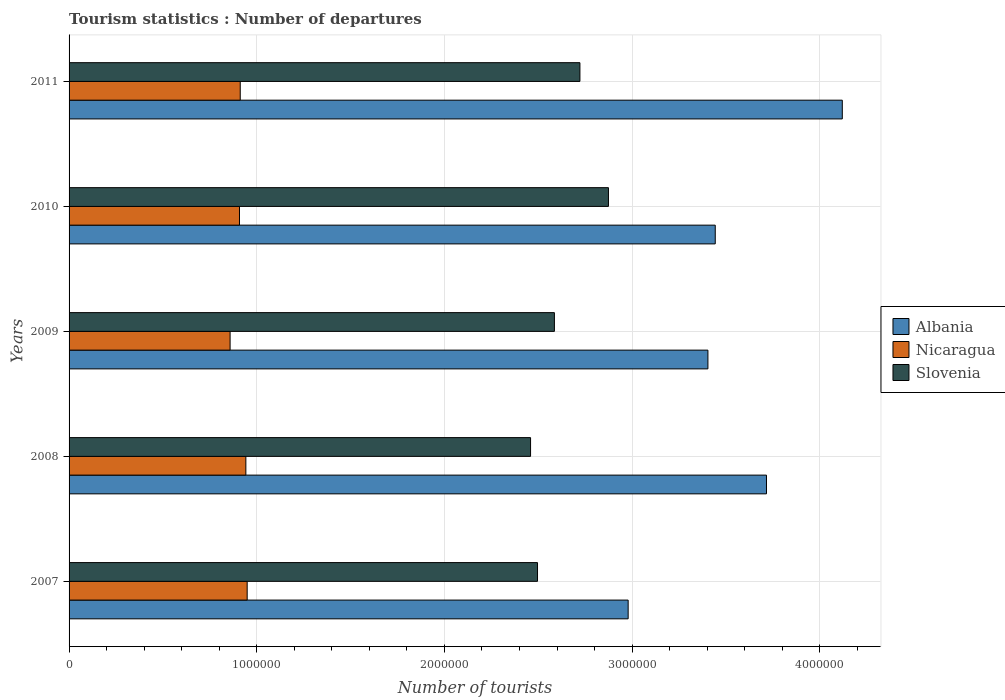Are the number of bars on each tick of the Y-axis equal?
Make the answer very short. Yes. How many bars are there on the 4th tick from the top?
Offer a terse response. 3. How many bars are there on the 3rd tick from the bottom?
Keep it short and to the point. 3. What is the label of the 5th group of bars from the top?
Your answer should be compact. 2007. In how many cases, is the number of bars for a given year not equal to the number of legend labels?
Ensure brevity in your answer.  0. What is the number of tourist departures in Slovenia in 2010?
Give a very brief answer. 2.87e+06. Across all years, what is the maximum number of tourist departures in Nicaragua?
Offer a terse response. 9.49e+05. Across all years, what is the minimum number of tourist departures in Nicaragua?
Offer a very short reply. 8.58e+05. What is the total number of tourist departures in Albania in the graph?
Your answer should be very brief. 1.77e+07. What is the difference between the number of tourist departures in Nicaragua in 2008 and that in 2011?
Provide a succinct answer. 3.00e+04. What is the difference between the number of tourist departures in Slovenia in 2009 and the number of tourist departures in Albania in 2008?
Ensure brevity in your answer.  -1.13e+06. What is the average number of tourist departures in Nicaragua per year?
Your answer should be compact. 9.14e+05. In the year 2009, what is the difference between the number of tourist departures in Slovenia and number of tourist departures in Albania?
Your answer should be very brief. -8.18e+05. What is the ratio of the number of tourist departures in Nicaragua in 2007 to that in 2010?
Offer a terse response. 1.05. What is the difference between the highest and the second highest number of tourist departures in Slovenia?
Make the answer very short. 1.52e+05. What is the difference between the highest and the lowest number of tourist departures in Albania?
Your answer should be very brief. 1.14e+06. In how many years, is the number of tourist departures in Albania greater than the average number of tourist departures in Albania taken over all years?
Make the answer very short. 2. Is the sum of the number of tourist departures in Albania in 2007 and 2009 greater than the maximum number of tourist departures in Nicaragua across all years?
Provide a short and direct response. Yes. What does the 1st bar from the top in 2008 represents?
Your answer should be compact. Slovenia. What does the 3rd bar from the bottom in 2009 represents?
Make the answer very short. Slovenia. Are all the bars in the graph horizontal?
Give a very brief answer. Yes. What is the difference between two consecutive major ticks on the X-axis?
Provide a short and direct response. 1.00e+06. Are the values on the major ticks of X-axis written in scientific E-notation?
Your answer should be compact. No. Does the graph contain any zero values?
Offer a terse response. No. How many legend labels are there?
Offer a very short reply. 3. What is the title of the graph?
Make the answer very short. Tourism statistics : Number of departures. Does "Botswana" appear as one of the legend labels in the graph?
Keep it short and to the point. No. What is the label or title of the X-axis?
Make the answer very short. Number of tourists. What is the label or title of the Y-axis?
Provide a succinct answer. Years. What is the Number of tourists of Albania in 2007?
Your answer should be compact. 2.98e+06. What is the Number of tourists in Nicaragua in 2007?
Your answer should be very brief. 9.49e+05. What is the Number of tourists of Slovenia in 2007?
Your response must be concise. 2.50e+06. What is the Number of tourists of Albania in 2008?
Offer a very short reply. 3.72e+06. What is the Number of tourists in Nicaragua in 2008?
Offer a terse response. 9.42e+05. What is the Number of tourists of Slovenia in 2008?
Your answer should be compact. 2.46e+06. What is the Number of tourists in Albania in 2009?
Ensure brevity in your answer.  3.40e+06. What is the Number of tourists of Nicaragua in 2009?
Provide a succinct answer. 8.58e+05. What is the Number of tourists of Slovenia in 2009?
Offer a very short reply. 2.59e+06. What is the Number of tourists in Albania in 2010?
Ensure brevity in your answer.  3.44e+06. What is the Number of tourists in Nicaragua in 2010?
Keep it short and to the point. 9.08e+05. What is the Number of tourists in Slovenia in 2010?
Your answer should be very brief. 2.87e+06. What is the Number of tourists in Albania in 2011?
Your answer should be very brief. 4.12e+06. What is the Number of tourists in Nicaragua in 2011?
Your answer should be very brief. 9.12e+05. What is the Number of tourists of Slovenia in 2011?
Your answer should be very brief. 2.72e+06. Across all years, what is the maximum Number of tourists of Albania?
Your answer should be compact. 4.12e+06. Across all years, what is the maximum Number of tourists of Nicaragua?
Offer a very short reply. 9.49e+05. Across all years, what is the maximum Number of tourists of Slovenia?
Provide a short and direct response. 2.87e+06. Across all years, what is the minimum Number of tourists in Albania?
Provide a short and direct response. 2.98e+06. Across all years, what is the minimum Number of tourists of Nicaragua?
Provide a succinct answer. 8.58e+05. Across all years, what is the minimum Number of tourists of Slovenia?
Your response must be concise. 2.46e+06. What is the total Number of tourists of Albania in the graph?
Give a very brief answer. 1.77e+07. What is the total Number of tourists in Nicaragua in the graph?
Offer a very short reply. 4.57e+06. What is the total Number of tourists of Slovenia in the graph?
Make the answer very short. 1.31e+07. What is the difference between the Number of tourists in Albania in 2007 and that in 2008?
Offer a terse response. -7.37e+05. What is the difference between the Number of tourists of Nicaragua in 2007 and that in 2008?
Offer a terse response. 7000. What is the difference between the Number of tourists of Slovenia in 2007 and that in 2008?
Ensure brevity in your answer.  3.70e+04. What is the difference between the Number of tourists in Albania in 2007 and that in 2009?
Give a very brief answer. -4.25e+05. What is the difference between the Number of tourists of Nicaragua in 2007 and that in 2009?
Offer a very short reply. 9.10e+04. What is the difference between the Number of tourists of Albania in 2007 and that in 2010?
Your answer should be compact. -4.64e+05. What is the difference between the Number of tourists of Nicaragua in 2007 and that in 2010?
Make the answer very short. 4.10e+04. What is the difference between the Number of tourists of Slovenia in 2007 and that in 2010?
Ensure brevity in your answer.  -3.78e+05. What is the difference between the Number of tourists of Albania in 2007 and that in 2011?
Offer a terse response. -1.14e+06. What is the difference between the Number of tourists of Nicaragua in 2007 and that in 2011?
Ensure brevity in your answer.  3.70e+04. What is the difference between the Number of tourists of Slovenia in 2007 and that in 2011?
Ensure brevity in your answer.  -2.26e+05. What is the difference between the Number of tourists of Albania in 2008 and that in 2009?
Give a very brief answer. 3.12e+05. What is the difference between the Number of tourists in Nicaragua in 2008 and that in 2009?
Provide a succinct answer. 8.40e+04. What is the difference between the Number of tourists of Slovenia in 2008 and that in 2009?
Your answer should be very brief. -1.27e+05. What is the difference between the Number of tourists in Albania in 2008 and that in 2010?
Provide a short and direct response. 2.73e+05. What is the difference between the Number of tourists of Nicaragua in 2008 and that in 2010?
Ensure brevity in your answer.  3.40e+04. What is the difference between the Number of tourists of Slovenia in 2008 and that in 2010?
Give a very brief answer. -4.15e+05. What is the difference between the Number of tourists of Albania in 2008 and that in 2011?
Your answer should be very brief. -4.04e+05. What is the difference between the Number of tourists of Slovenia in 2008 and that in 2011?
Ensure brevity in your answer.  -2.63e+05. What is the difference between the Number of tourists in Albania in 2009 and that in 2010?
Keep it short and to the point. -3.90e+04. What is the difference between the Number of tourists of Slovenia in 2009 and that in 2010?
Provide a short and direct response. -2.88e+05. What is the difference between the Number of tourists of Albania in 2009 and that in 2011?
Keep it short and to the point. -7.16e+05. What is the difference between the Number of tourists in Nicaragua in 2009 and that in 2011?
Offer a terse response. -5.40e+04. What is the difference between the Number of tourists of Slovenia in 2009 and that in 2011?
Provide a short and direct response. -1.36e+05. What is the difference between the Number of tourists of Albania in 2010 and that in 2011?
Give a very brief answer. -6.77e+05. What is the difference between the Number of tourists in Nicaragua in 2010 and that in 2011?
Give a very brief answer. -4000. What is the difference between the Number of tourists of Slovenia in 2010 and that in 2011?
Provide a short and direct response. 1.52e+05. What is the difference between the Number of tourists in Albania in 2007 and the Number of tourists in Nicaragua in 2008?
Your answer should be compact. 2.04e+06. What is the difference between the Number of tourists in Albania in 2007 and the Number of tourists in Slovenia in 2008?
Your answer should be compact. 5.20e+05. What is the difference between the Number of tourists of Nicaragua in 2007 and the Number of tourists of Slovenia in 2008?
Offer a terse response. -1.51e+06. What is the difference between the Number of tourists in Albania in 2007 and the Number of tourists in Nicaragua in 2009?
Your response must be concise. 2.12e+06. What is the difference between the Number of tourists of Albania in 2007 and the Number of tourists of Slovenia in 2009?
Provide a short and direct response. 3.93e+05. What is the difference between the Number of tourists in Nicaragua in 2007 and the Number of tourists in Slovenia in 2009?
Provide a short and direct response. -1.64e+06. What is the difference between the Number of tourists of Albania in 2007 and the Number of tourists of Nicaragua in 2010?
Your response must be concise. 2.07e+06. What is the difference between the Number of tourists in Albania in 2007 and the Number of tourists in Slovenia in 2010?
Make the answer very short. 1.05e+05. What is the difference between the Number of tourists in Nicaragua in 2007 and the Number of tourists in Slovenia in 2010?
Keep it short and to the point. -1.92e+06. What is the difference between the Number of tourists in Albania in 2007 and the Number of tourists in Nicaragua in 2011?
Keep it short and to the point. 2.07e+06. What is the difference between the Number of tourists of Albania in 2007 and the Number of tourists of Slovenia in 2011?
Your answer should be very brief. 2.57e+05. What is the difference between the Number of tourists of Nicaragua in 2007 and the Number of tourists of Slovenia in 2011?
Keep it short and to the point. -1.77e+06. What is the difference between the Number of tourists of Albania in 2008 and the Number of tourists of Nicaragua in 2009?
Give a very brief answer. 2.86e+06. What is the difference between the Number of tourists in Albania in 2008 and the Number of tourists in Slovenia in 2009?
Your answer should be compact. 1.13e+06. What is the difference between the Number of tourists in Nicaragua in 2008 and the Number of tourists in Slovenia in 2009?
Make the answer very short. -1.64e+06. What is the difference between the Number of tourists in Albania in 2008 and the Number of tourists in Nicaragua in 2010?
Your response must be concise. 2.81e+06. What is the difference between the Number of tourists of Albania in 2008 and the Number of tourists of Slovenia in 2010?
Provide a succinct answer. 8.42e+05. What is the difference between the Number of tourists in Nicaragua in 2008 and the Number of tourists in Slovenia in 2010?
Your response must be concise. -1.93e+06. What is the difference between the Number of tourists of Albania in 2008 and the Number of tourists of Nicaragua in 2011?
Provide a succinct answer. 2.80e+06. What is the difference between the Number of tourists of Albania in 2008 and the Number of tourists of Slovenia in 2011?
Your answer should be very brief. 9.94e+05. What is the difference between the Number of tourists of Nicaragua in 2008 and the Number of tourists of Slovenia in 2011?
Keep it short and to the point. -1.78e+06. What is the difference between the Number of tourists in Albania in 2009 and the Number of tourists in Nicaragua in 2010?
Offer a terse response. 2.50e+06. What is the difference between the Number of tourists in Albania in 2009 and the Number of tourists in Slovenia in 2010?
Offer a very short reply. 5.30e+05. What is the difference between the Number of tourists in Nicaragua in 2009 and the Number of tourists in Slovenia in 2010?
Your answer should be compact. -2.02e+06. What is the difference between the Number of tourists of Albania in 2009 and the Number of tourists of Nicaragua in 2011?
Provide a short and direct response. 2.49e+06. What is the difference between the Number of tourists in Albania in 2009 and the Number of tourists in Slovenia in 2011?
Offer a very short reply. 6.82e+05. What is the difference between the Number of tourists of Nicaragua in 2009 and the Number of tourists of Slovenia in 2011?
Ensure brevity in your answer.  -1.86e+06. What is the difference between the Number of tourists of Albania in 2010 and the Number of tourists of Nicaragua in 2011?
Ensure brevity in your answer.  2.53e+06. What is the difference between the Number of tourists in Albania in 2010 and the Number of tourists in Slovenia in 2011?
Provide a short and direct response. 7.21e+05. What is the difference between the Number of tourists in Nicaragua in 2010 and the Number of tourists in Slovenia in 2011?
Your answer should be compact. -1.81e+06. What is the average Number of tourists of Albania per year?
Ensure brevity in your answer.  3.53e+06. What is the average Number of tourists in Nicaragua per year?
Your response must be concise. 9.14e+05. What is the average Number of tourists of Slovenia per year?
Your response must be concise. 2.63e+06. In the year 2007, what is the difference between the Number of tourists in Albania and Number of tourists in Nicaragua?
Make the answer very short. 2.03e+06. In the year 2007, what is the difference between the Number of tourists in Albania and Number of tourists in Slovenia?
Your response must be concise. 4.83e+05. In the year 2007, what is the difference between the Number of tourists of Nicaragua and Number of tourists of Slovenia?
Your response must be concise. -1.55e+06. In the year 2008, what is the difference between the Number of tourists in Albania and Number of tourists in Nicaragua?
Your answer should be compact. 2.77e+06. In the year 2008, what is the difference between the Number of tourists of Albania and Number of tourists of Slovenia?
Offer a very short reply. 1.26e+06. In the year 2008, what is the difference between the Number of tourists of Nicaragua and Number of tourists of Slovenia?
Offer a very short reply. -1.52e+06. In the year 2009, what is the difference between the Number of tourists in Albania and Number of tourists in Nicaragua?
Keep it short and to the point. 2.55e+06. In the year 2009, what is the difference between the Number of tourists in Albania and Number of tourists in Slovenia?
Your answer should be very brief. 8.18e+05. In the year 2009, what is the difference between the Number of tourists of Nicaragua and Number of tourists of Slovenia?
Make the answer very short. -1.73e+06. In the year 2010, what is the difference between the Number of tourists of Albania and Number of tourists of Nicaragua?
Your response must be concise. 2.54e+06. In the year 2010, what is the difference between the Number of tourists of Albania and Number of tourists of Slovenia?
Provide a short and direct response. 5.69e+05. In the year 2010, what is the difference between the Number of tourists of Nicaragua and Number of tourists of Slovenia?
Your answer should be compact. -1.97e+06. In the year 2011, what is the difference between the Number of tourists in Albania and Number of tourists in Nicaragua?
Make the answer very short. 3.21e+06. In the year 2011, what is the difference between the Number of tourists of Albania and Number of tourists of Slovenia?
Keep it short and to the point. 1.40e+06. In the year 2011, what is the difference between the Number of tourists of Nicaragua and Number of tourists of Slovenia?
Provide a succinct answer. -1.81e+06. What is the ratio of the Number of tourists of Albania in 2007 to that in 2008?
Provide a succinct answer. 0.8. What is the ratio of the Number of tourists in Nicaragua in 2007 to that in 2008?
Provide a short and direct response. 1.01. What is the ratio of the Number of tourists in Slovenia in 2007 to that in 2008?
Your answer should be very brief. 1.01. What is the ratio of the Number of tourists of Albania in 2007 to that in 2009?
Provide a short and direct response. 0.88. What is the ratio of the Number of tourists of Nicaragua in 2007 to that in 2009?
Offer a very short reply. 1.11. What is the ratio of the Number of tourists of Slovenia in 2007 to that in 2009?
Your answer should be compact. 0.97. What is the ratio of the Number of tourists in Albania in 2007 to that in 2010?
Provide a short and direct response. 0.87. What is the ratio of the Number of tourists in Nicaragua in 2007 to that in 2010?
Give a very brief answer. 1.05. What is the ratio of the Number of tourists in Slovenia in 2007 to that in 2010?
Offer a very short reply. 0.87. What is the ratio of the Number of tourists in Albania in 2007 to that in 2011?
Your answer should be compact. 0.72. What is the ratio of the Number of tourists of Nicaragua in 2007 to that in 2011?
Your answer should be very brief. 1.04. What is the ratio of the Number of tourists of Slovenia in 2007 to that in 2011?
Make the answer very short. 0.92. What is the ratio of the Number of tourists in Albania in 2008 to that in 2009?
Your response must be concise. 1.09. What is the ratio of the Number of tourists of Nicaragua in 2008 to that in 2009?
Ensure brevity in your answer.  1.1. What is the ratio of the Number of tourists in Slovenia in 2008 to that in 2009?
Offer a very short reply. 0.95. What is the ratio of the Number of tourists of Albania in 2008 to that in 2010?
Your response must be concise. 1.08. What is the ratio of the Number of tourists of Nicaragua in 2008 to that in 2010?
Give a very brief answer. 1.04. What is the ratio of the Number of tourists of Slovenia in 2008 to that in 2010?
Provide a short and direct response. 0.86. What is the ratio of the Number of tourists of Albania in 2008 to that in 2011?
Provide a succinct answer. 0.9. What is the ratio of the Number of tourists of Nicaragua in 2008 to that in 2011?
Offer a very short reply. 1.03. What is the ratio of the Number of tourists in Slovenia in 2008 to that in 2011?
Keep it short and to the point. 0.9. What is the ratio of the Number of tourists of Albania in 2009 to that in 2010?
Your answer should be very brief. 0.99. What is the ratio of the Number of tourists in Nicaragua in 2009 to that in 2010?
Offer a very short reply. 0.94. What is the ratio of the Number of tourists of Slovenia in 2009 to that in 2010?
Provide a succinct answer. 0.9. What is the ratio of the Number of tourists in Albania in 2009 to that in 2011?
Make the answer very short. 0.83. What is the ratio of the Number of tourists in Nicaragua in 2009 to that in 2011?
Make the answer very short. 0.94. What is the ratio of the Number of tourists of Albania in 2010 to that in 2011?
Your answer should be very brief. 0.84. What is the ratio of the Number of tourists in Nicaragua in 2010 to that in 2011?
Offer a very short reply. 1. What is the ratio of the Number of tourists in Slovenia in 2010 to that in 2011?
Keep it short and to the point. 1.06. What is the difference between the highest and the second highest Number of tourists in Albania?
Make the answer very short. 4.04e+05. What is the difference between the highest and the second highest Number of tourists in Nicaragua?
Offer a very short reply. 7000. What is the difference between the highest and the second highest Number of tourists in Slovenia?
Offer a terse response. 1.52e+05. What is the difference between the highest and the lowest Number of tourists in Albania?
Your response must be concise. 1.14e+06. What is the difference between the highest and the lowest Number of tourists in Nicaragua?
Ensure brevity in your answer.  9.10e+04. What is the difference between the highest and the lowest Number of tourists in Slovenia?
Give a very brief answer. 4.15e+05. 